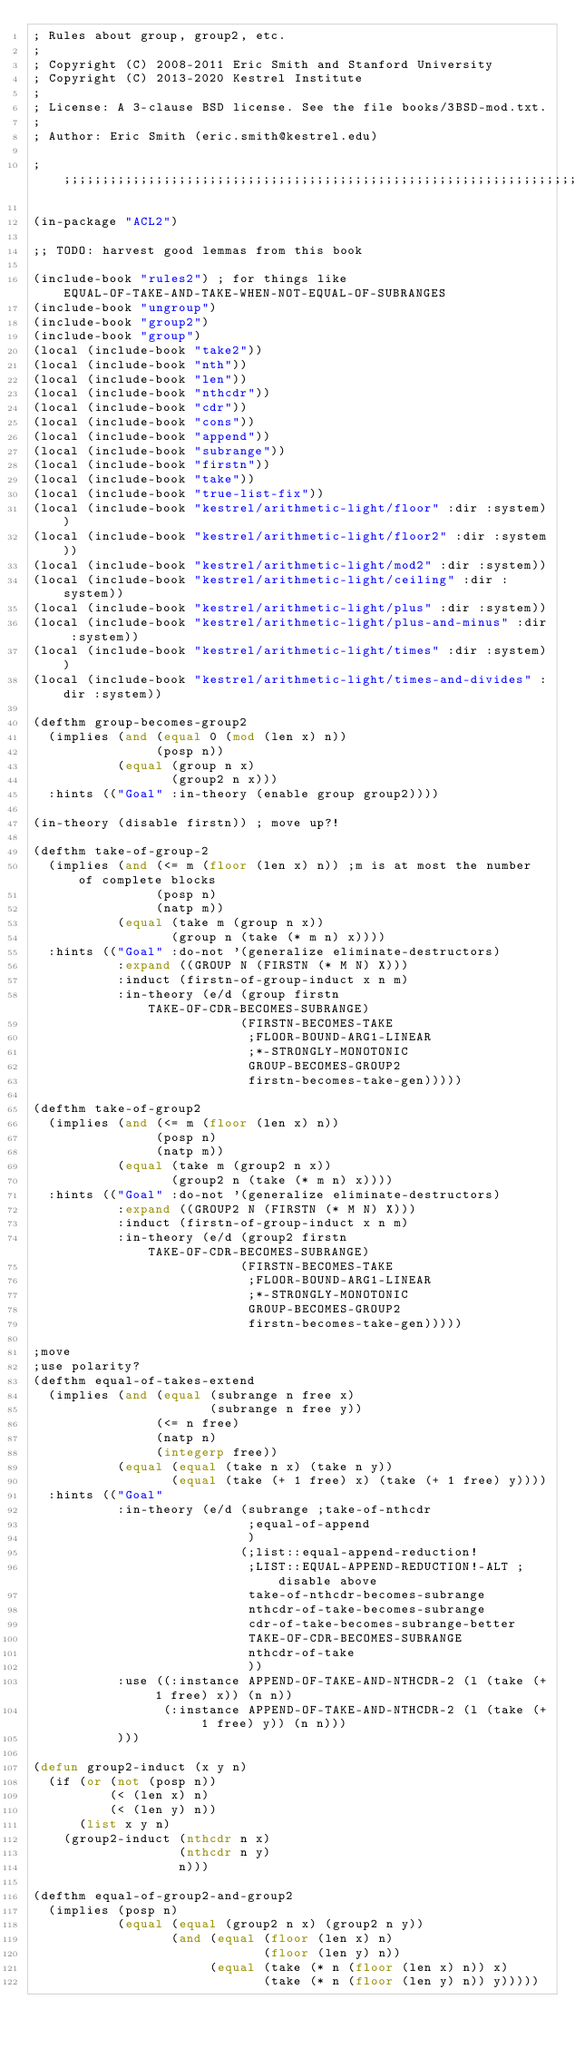Convert code to text. <code><loc_0><loc_0><loc_500><loc_500><_Lisp_>; Rules about group, group2, etc.
;
; Copyright (C) 2008-2011 Eric Smith and Stanford University
; Copyright (C) 2013-2020 Kestrel Institute
;
; License: A 3-clause BSD license. See the file books/3BSD-mod.txt.
;
; Author: Eric Smith (eric.smith@kestrel.edu)

;;;;;;;;;;;;;;;;;;;;;;;;;;;;;;;;;;;;;;;;;;;;;;;;;;;;;;;;;;;;;;;;;;;;;;;;;;;;;;;;

(in-package "ACL2")

;; TODO: harvest good lemmas from this book

(include-book "rules2") ; for things like EQUAL-OF-TAKE-AND-TAKE-WHEN-NOT-EQUAL-OF-SUBRANGES
(include-book "ungroup")
(include-book "group2")
(include-book "group")
(local (include-book "take2"))
(local (include-book "nth"))
(local (include-book "len"))
(local (include-book "nthcdr"))
(local (include-book "cdr"))
(local (include-book "cons"))
(local (include-book "append"))
(local (include-book "subrange"))
(local (include-book "firstn"))
(local (include-book "take"))
(local (include-book "true-list-fix"))
(local (include-book "kestrel/arithmetic-light/floor" :dir :system))
(local (include-book "kestrel/arithmetic-light/floor2" :dir :system))
(local (include-book "kestrel/arithmetic-light/mod2" :dir :system))
(local (include-book "kestrel/arithmetic-light/ceiling" :dir :system))
(local (include-book "kestrel/arithmetic-light/plus" :dir :system))
(local (include-book "kestrel/arithmetic-light/plus-and-minus" :dir :system))
(local (include-book "kestrel/arithmetic-light/times" :dir :system))
(local (include-book "kestrel/arithmetic-light/times-and-divides" :dir :system))

(defthm group-becomes-group2
  (implies (and (equal 0 (mod (len x) n))
                (posp n))
           (equal (group n x)
                  (group2 n x)))
  :hints (("Goal" :in-theory (enable group group2))))

(in-theory (disable firstn)) ; move up?!

(defthm take-of-group-2
  (implies (and (<= m (floor (len x) n)) ;m is at most the number of complete blocks
                (posp n)
                (natp m))
           (equal (take m (group n x))
                  (group n (take (* m n) x))))
  :hints (("Goal" :do-not '(generalize eliminate-destructors)
           :expand ((GROUP N (FIRSTN (* M N) X)))
           :induct (firstn-of-group-induct x n m)
           :in-theory (e/d (group firstn TAKE-OF-CDR-BECOMES-SUBRANGE)
                           (FIRSTN-BECOMES-TAKE
                            ;FLOOR-BOUND-ARG1-LINEAR
                            ;*-STRONGLY-MONOTONIC
                            GROUP-BECOMES-GROUP2
                            firstn-becomes-take-gen)))))

(defthm take-of-group2
  (implies (and (<= m (floor (len x) n))
                (posp n)
                (natp m))
           (equal (take m (group2 n x))
                  (group2 n (take (* m n) x))))
  :hints (("Goal" :do-not '(generalize eliminate-destructors)
           :expand ((GROUP2 N (FIRSTN (* M N) X)))
           :induct (firstn-of-group-induct x n m)
           :in-theory (e/d (group2 firstn TAKE-OF-CDR-BECOMES-SUBRANGE)
                           (FIRSTN-BECOMES-TAKE
                            ;FLOOR-BOUND-ARG1-LINEAR
                            ;*-STRONGLY-MONOTONIC
                            GROUP-BECOMES-GROUP2
                            firstn-becomes-take-gen)))))

;move
;use polarity?
(defthm equal-of-takes-extend
  (implies (and (equal (subrange n free x)
                       (subrange n free y))
                (<= n free)
                (natp n)
                (integerp free))
           (equal (equal (take n x) (take n y))
                  (equal (take (+ 1 free) x) (take (+ 1 free) y))))
  :hints (("Goal"
           :in-theory (e/d (subrange ;take-of-nthcdr
                            ;equal-of-append
                            )
                           (;list::equal-append-reduction!
                            ;LIST::EQUAL-APPEND-REDUCTION!-ALT ;disable above
                            take-of-nthcdr-becomes-subrange
                            nthcdr-of-take-becomes-subrange
                            cdr-of-take-becomes-subrange-better
                            TAKE-OF-CDR-BECOMES-SUBRANGE
                            nthcdr-of-take
                            ))
           :use ((:instance APPEND-OF-TAKE-AND-NTHCDR-2 (l (take (+ 1 free) x)) (n n))
                 (:instance APPEND-OF-TAKE-AND-NTHCDR-2 (l (take (+ 1 free) y)) (n n)))
           )))

(defun group2-induct (x y n)
  (if (or (not (posp n))
          (< (len x) n)
          (< (len y) n))
      (list x y n)
    (group2-induct (nthcdr n x)
                   (nthcdr n y)
                   n)))

(defthm equal-of-group2-and-group2
  (implies (posp n)
           (equal (equal (group2 n x) (group2 n y))
                  (and (equal (floor (len x) n)
                              (floor (len y) n))
                       (equal (take (* n (floor (len x) n)) x)
                              (take (* n (floor (len y) n)) y)))))</code> 